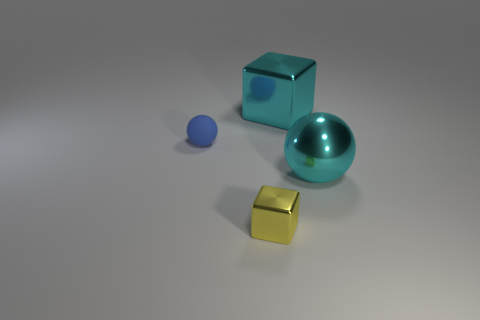There is a big metallic object that is right of the large metal cube; is there a tiny matte sphere in front of it?
Your response must be concise. No. What is the shape of the tiny object that is the same material as the cyan cube?
Offer a terse response. Cube. Is the size of the cyan metallic thing in front of the small blue matte thing the same as the cyan metallic object behind the matte thing?
Your answer should be compact. Yes. Are there more small yellow objects in front of the matte object than big cyan shiny things behind the large cyan block?
Give a very brief answer. Yes. What number of other objects are there of the same color as the big cube?
Offer a terse response. 1. Do the big ball and the large object that is behind the cyan sphere have the same color?
Provide a succinct answer. Yes. What number of rubber balls are on the left side of the cyan thing in front of the big cyan cube?
Your answer should be compact. 1. Is there any other thing that is made of the same material as the blue thing?
Offer a terse response. No. There is a ball on the left side of the big thing that is in front of the cube on the right side of the yellow cube; what is its material?
Ensure brevity in your answer.  Rubber. What material is the thing that is both behind the big cyan metallic ball and in front of the large cyan metal cube?
Your response must be concise. Rubber. 